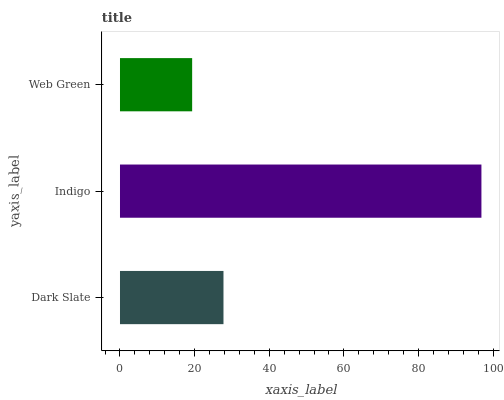Is Web Green the minimum?
Answer yes or no. Yes. Is Indigo the maximum?
Answer yes or no. Yes. Is Indigo the minimum?
Answer yes or no. No. Is Web Green the maximum?
Answer yes or no. No. Is Indigo greater than Web Green?
Answer yes or no. Yes. Is Web Green less than Indigo?
Answer yes or no. Yes. Is Web Green greater than Indigo?
Answer yes or no. No. Is Indigo less than Web Green?
Answer yes or no. No. Is Dark Slate the high median?
Answer yes or no. Yes. Is Dark Slate the low median?
Answer yes or no. Yes. Is Indigo the high median?
Answer yes or no. No. Is Web Green the low median?
Answer yes or no. No. 